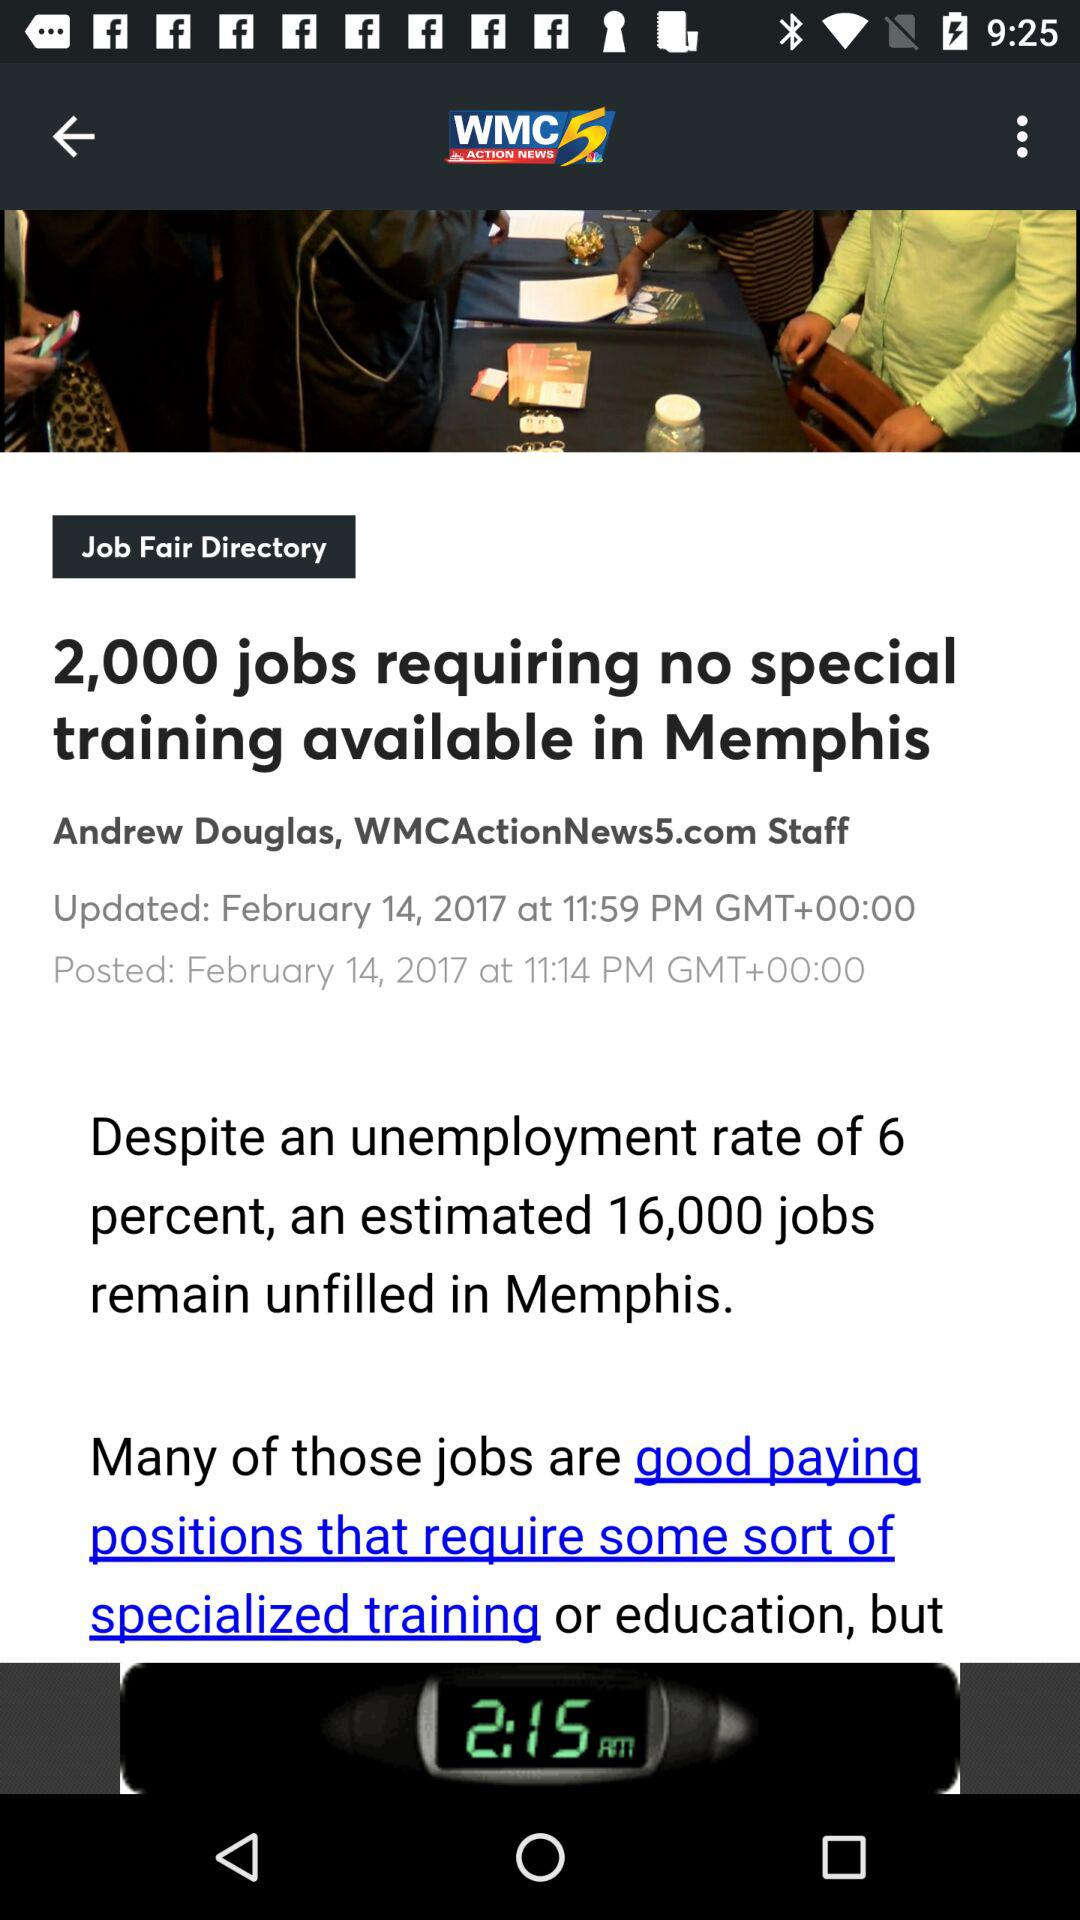What is the name of the television station? The name of the television station is "WMC ACTION NEWS 5". 